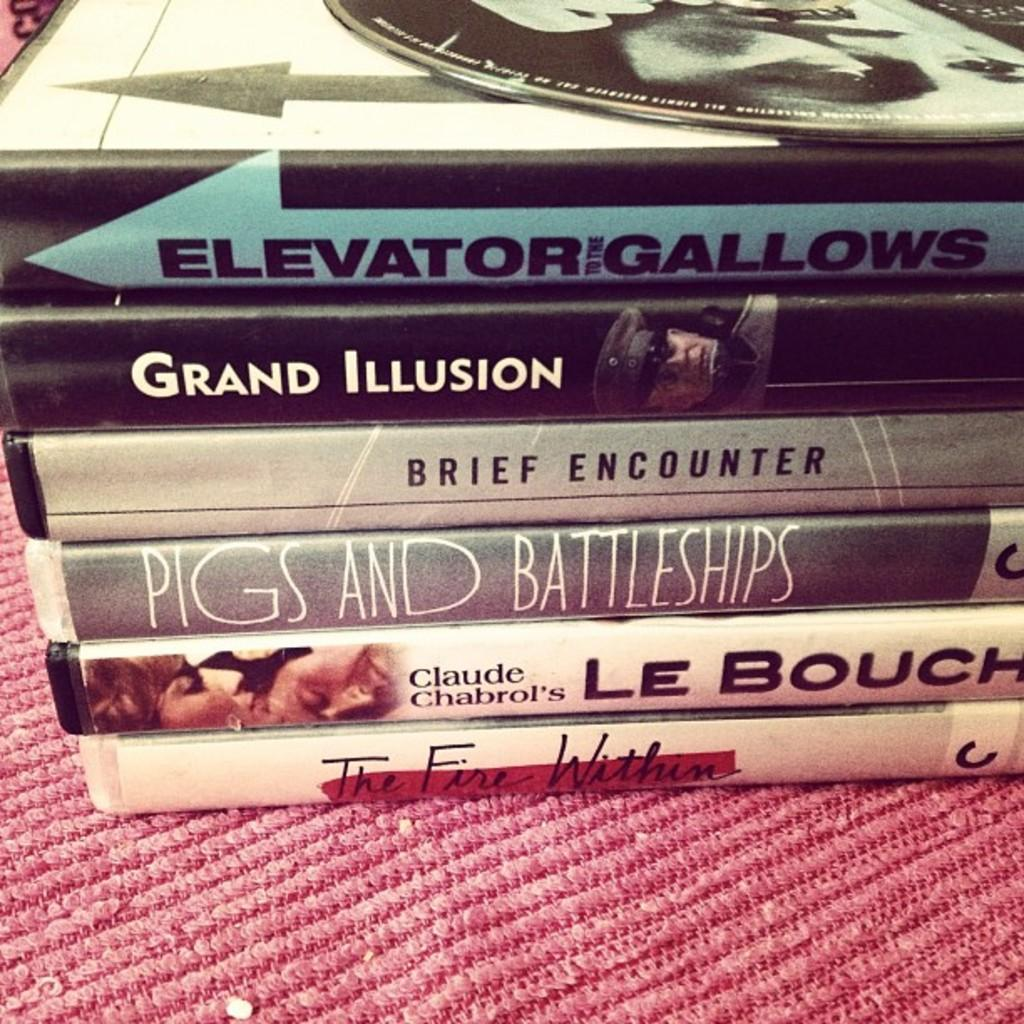<image>
Write a terse but informative summary of the picture. A couple books titled " Elevator Gallows", " Grand Illusion", and " Brief Encounter". 